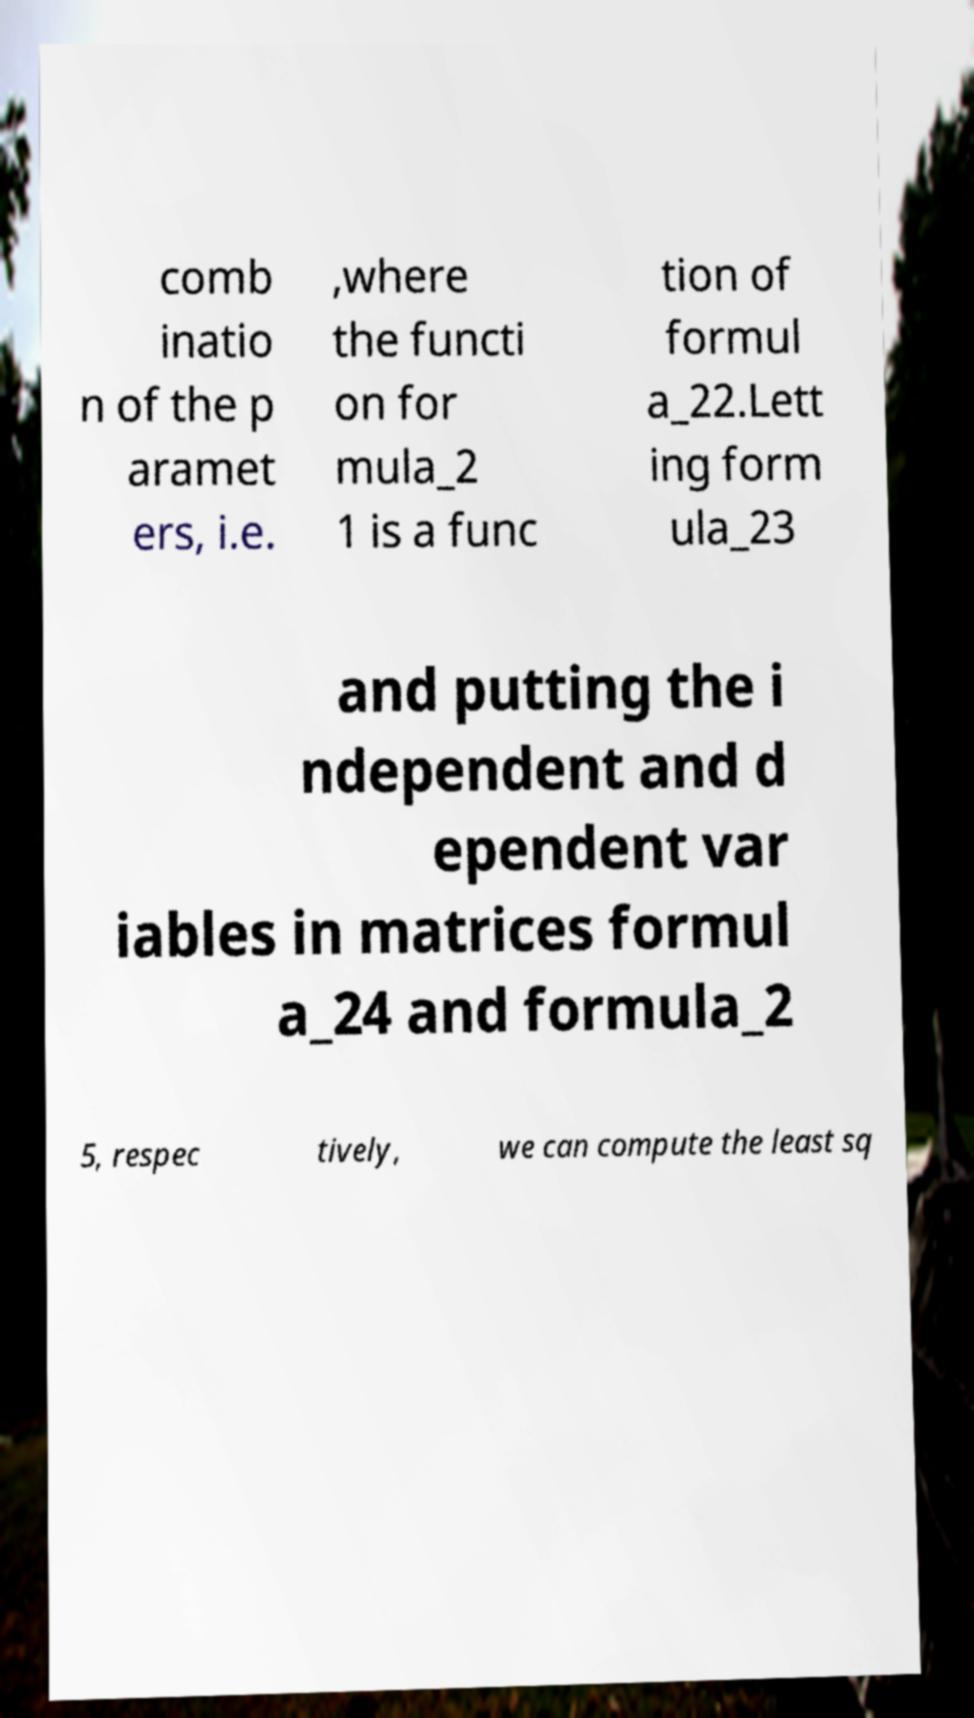Please read and relay the text visible in this image. What does it say? comb inatio n of the p aramet ers, i.e. ,where the functi on for mula_2 1 is a func tion of formul a_22.Lett ing form ula_23 and putting the i ndependent and d ependent var iables in matrices formul a_24 and formula_2 5, respec tively, we can compute the least sq 